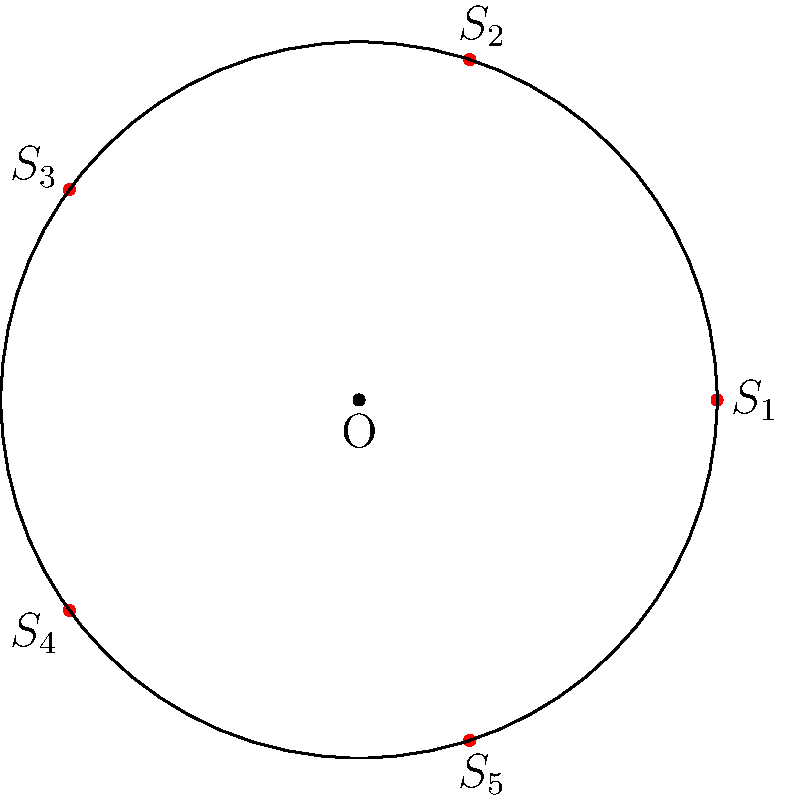In your latest installation, you've arranged five sculptural elements $(S_1, S_2, S_3, S_4, S_5)$ symmetrically around a central point O, as shown in the diagram. The group of rotational symmetries of this arrangement is isomorphic to a well-known group. Identify this group and determine its order. How does this relate to Islay Taylor's work on symmetry in contemporary art? To solve this problem, let's follow these steps:

1. Observe the arrangement: The sculptural elements are placed at equal angles around a central point, forming a regular pentagon.

2. Identify the symmetries: This arrangement has rotational symmetry. It remains unchanged when rotated by multiples of 72° (360°/5) around the central point O.

3. Determine the possible rotations:
   - Rotation by 0° (identity)
   - Rotation by 72°
   - Rotation by 144°
   - Rotation by 216°
   - Rotation by 288°

4. Count the number of symmetries: There are 5 distinct rotations that preserve the arrangement.

5. Identify the group: This group of rotations is isomorphic to the cyclic group of order 5, denoted as $C_5$ or $\mathbb{Z}_5$.

6. Determine the order of the group: The order is 5, corresponding to the 5 distinct rotations.

7. Relation to Islay Taylor's work: Islay Taylor often explores symmetry in her contemporary art installations. This arrangement reflects the concept of cyclic symmetry, which Taylor has incorporated in her works to create a sense of balance and harmony. The group structure $C_5$ represents the mathematical underpinning of this artistic choice, demonstrating the intersection of art and mathematics in contemporary sculpture.
Answer: $C_5$ (or $\mathbb{Z}_5$), order 5 